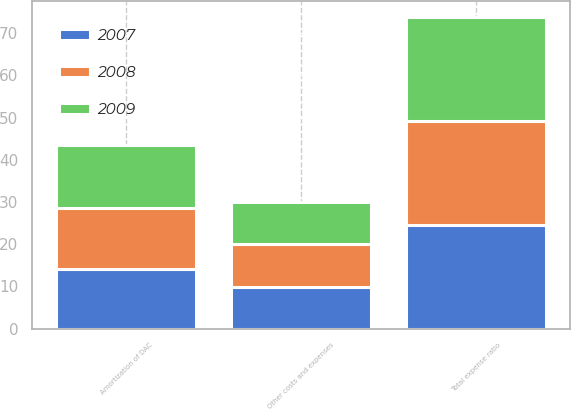Convert chart. <chart><loc_0><loc_0><loc_500><loc_500><stacked_bar_chart><ecel><fcel>Amortization of DAC<fcel>Other costs and expenses<fcel>Total expense ratio<nl><fcel>2007<fcel>14.2<fcel>9.9<fcel>24.5<nl><fcel>2008<fcel>14.4<fcel>10.2<fcel>24.7<nl><fcel>2009<fcel>14.8<fcel>9.8<fcel>24.7<nl></chart> 